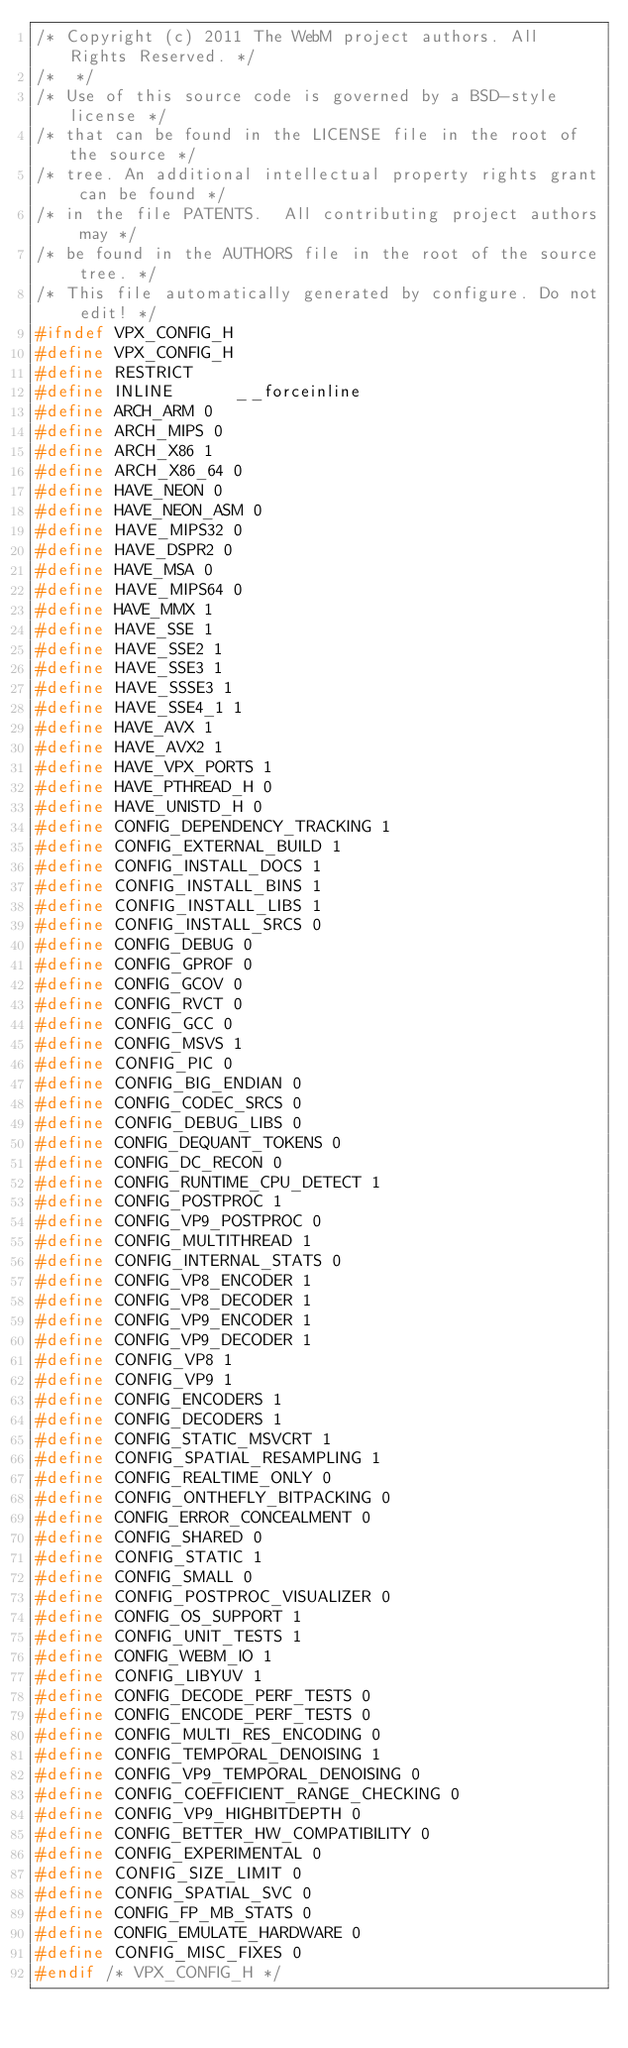<code> <loc_0><loc_0><loc_500><loc_500><_C_>/* Copyright (c) 2011 The WebM project authors. All Rights Reserved. */
/*  */
/* Use of this source code is governed by a BSD-style license */
/* that can be found in the LICENSE file in the root of the source */
/* tree. An additional intellectual property rights grant can be found */
/* in the file PATENTS.  All contributing project authors may */
/* be found in the AUTHORS file in the root of the source tree. */
/* This file automatically generated by configure. Do not edit! */
#ifndef VPX_CONFIG_H
#define VPX_CONFIG_H
#define RESTRICT    
#define INLINE      __forceinline
#define ARCH_ARM 0
#define ARCH_MIPS 0
#define ARCH_X86 1
#define ARCH_X86_64 0
#define HAVE_NEON 0
#define HAVE_NEON_ASM 0
#define HAVE_MIPS32 0
#define HAVE_DSPR2 0
#define HAVE_MSA 0
#define HAVE_MIPS64 0
#define HAVE_MMX 1
#define HAVE_SSE 1
#define HAVE_SSE2 1
#define HAVE_SSE3 1
#define HAVE_SSSE3 1
#define HAVE_SSE4_1 1
#define HAVE_AVX 1
#define HAVE_AVX2 1
#define HAVE_VPX_PORTS 1
#define HAVE_PTHREAD_H 0
#define HAVE_UNISTD_H 0
#define CONFIG_DEPENDENCY_TRACKING 1
#define CONFIG_EXTERNAL_BUILD 1
#define CONFIG_INSTALL_DOCS 1
#define CONFIG_INSTALL_BINS 1
#define CONFIG_INSTALL_LIBS 1
#define CONFIG_INSTALL_SRCS 0
#define CONFIG_DEBUG 0
#define CONFIG_GPROF 0
#define CONFIG_GCOV 0
#define CONFIG_RVCT 0
#define CONFIG_GCC 0
#define CONFIG_MSVS 1
#define CONFIG_PIC 0
#define CONFIG_BIG_ENDIAN 0
#define CONFIG_CODEC_SRCS 0
#define CONFIG_DEBUG_LIBS 0
#define CONFIG_DEQUANT_TOKENS 0
#define CONFIG_DC_RECON 0
#define CONFIG_RUNTIME_CPU_DETECT 1
#define CONFIG_POSTPROC 1
#define CONFIG_VP9_POSTPROC 0
#define CONFIG_MULTITHREAD 1
#define CONFIG_INTERNAL_STATS 0
#define CONFIG_VP8_ENCODER 1
#define CONFIG_VP8_DECODER 1
#define CONFIG_VP9_ENCODER 1
#define CONFIG_VP9_DECODER 1
#define CONFIG_VP8 1
#define CONFIG_VP9 1
#define CONFIG_ENCODERS 1
#define CONFIG_DECODERS 1
#define CONFIG_STATIC_MSVCRT 1
#define CONFIG_SPATIAL_RESAMPLING 1
#define CONFIG_REALTIME_ONLY 0
#define CONFIG_ONTHEFLY_BITPACKING 0
#define CONFIG_ERROR_CONCEALMENT 0
#define CONFIG_SHARED 0
#define CONFIG_STATIC 1
#define CONFIG_SMALL 0
#define CONFIG_POSTPROC_VISUALIZER 0
#define CONFIG_OS_SUPPORT 1
#define CONFIG_UNIT_TESTS 1
#define CONFIG_WEBM_IO 1
#define CONFIG_LIBYUV 1
#define CONFIG_DECODE_PERF_TESTS 0
#define CONFIG_ENCODE_PERF_TESTS 0
#define CONFIG_MULTI_RES_ENCODING 0
#define CONFIG_TEMPORAL_DENOISING 1
#define CONFIG_VP9_TEMPORAL_DENOISING 0
#define CONFIG_COEFFICIENT_RANGE_CHECKING 0
#define CONFIG_VP9_HIGHBITDEPTH 0
#define CONFIG_BETTER_HW_COMPATIBILITY 0
#define CONFIG_EXPERIMENTAL 0
#define CONFIG_SIZE_LIMIT 0
#define CONFIG_SPATIAL_SVC 0
#define CONFIG_FP_MB_STATS 0
#define CONFIG_EMULATE_HARDWARE 0
#define CONFIG_MISC_FIXES 0
#endif /* VPX_CONFIG_H */
</code> 